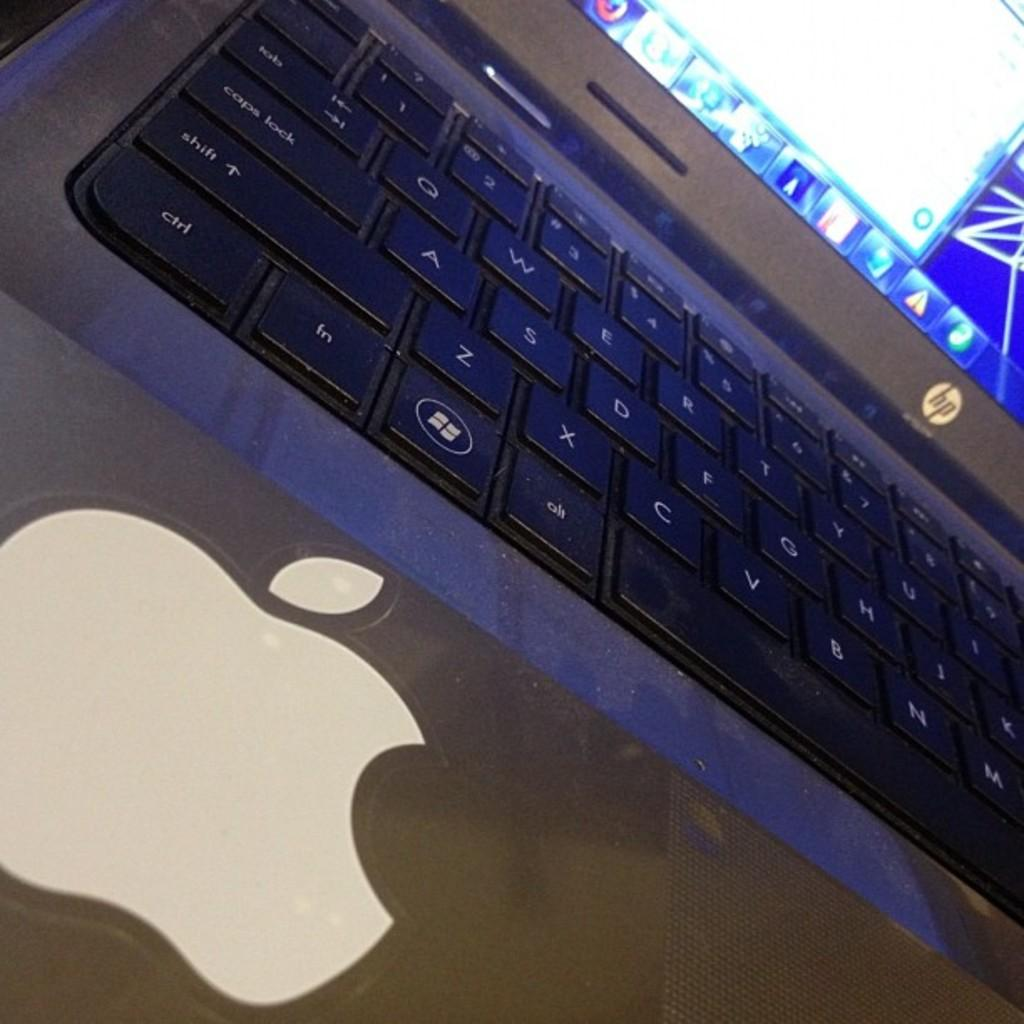What electronic device is present in the image? There is a laptop in the image. What can be seen on the laptop screen? There are applications visible on the laptop screen. What type of border is present around the laptop in the image? There is no border visible around the laptop in the image. Is there a dock for the laptop in the image? There is no dock visible in the image. 